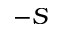<formula> <loc_0><loc_0><loc_500><loc_500>- S</formula> 